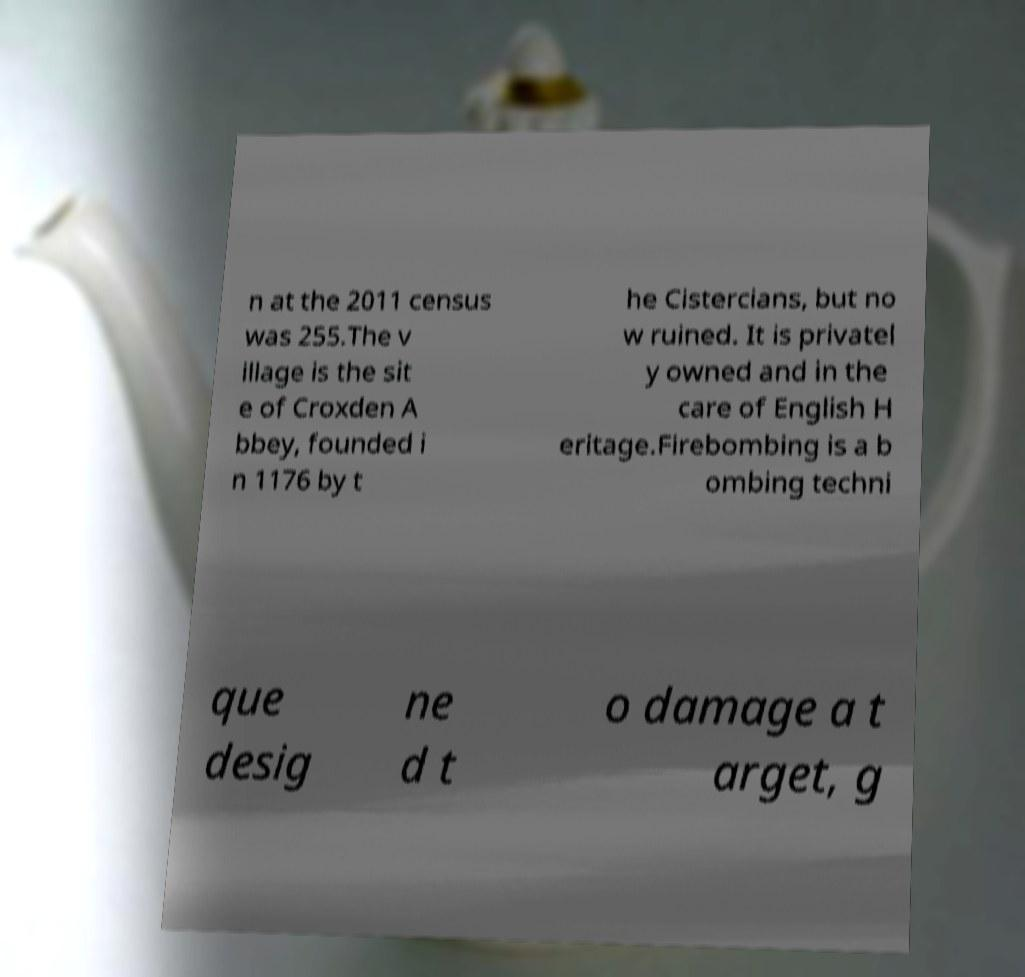Please read and relay the text visible in this image. What does it say? n at the 2011 census was 255.The v illage is the sit e of Croxden A bbey, founded i n 1176 by t he Cistercians, but no w ruined. It is privatel y owned and in the care of English H eritage.Firebombing is a b ombing techni que desig ne d t o damage a t arget, g 